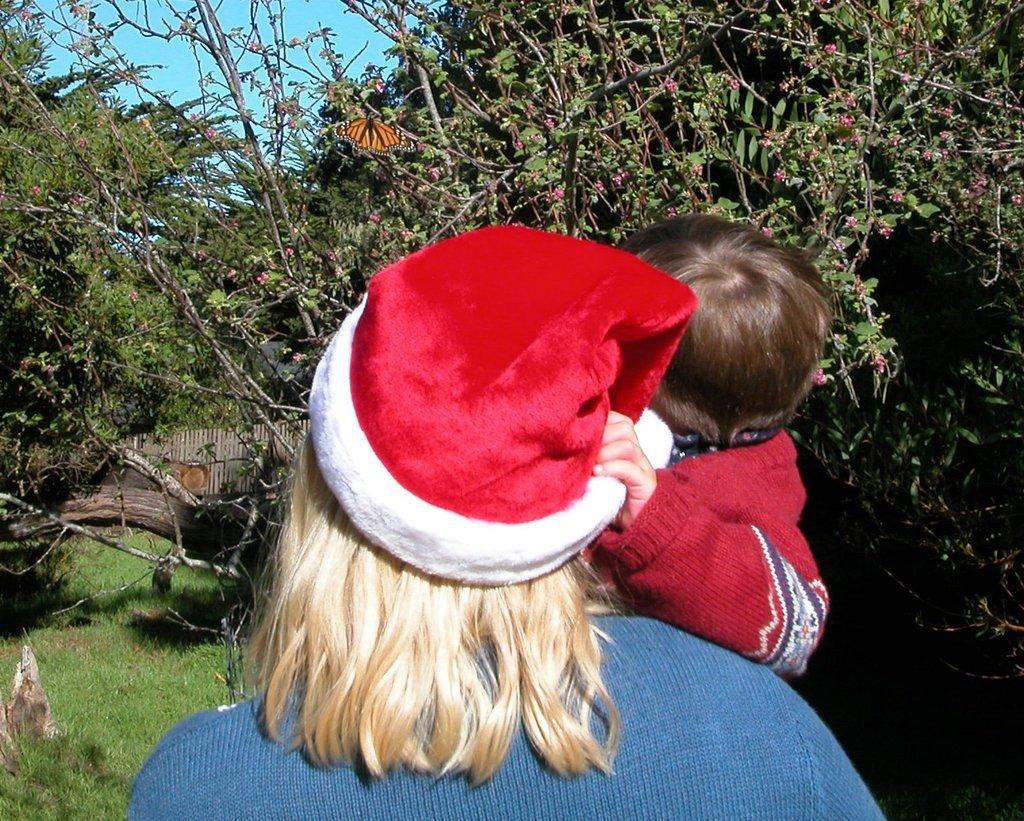Who is the main subject in the image? There is a woman in the image. What is the woman doing in the image? The woman is holding a baby. What can be seen in the background of the image? There are many trees in the background of the image. What type of architectural feature is visible behind the trees? There is a fencing behind the trees in the background. What type of loaf can be seen in the image? There is no loaf present in the image. What type of grass is visible in the image? The image does not show any grass; it only shows trees and a fencing in the background. 